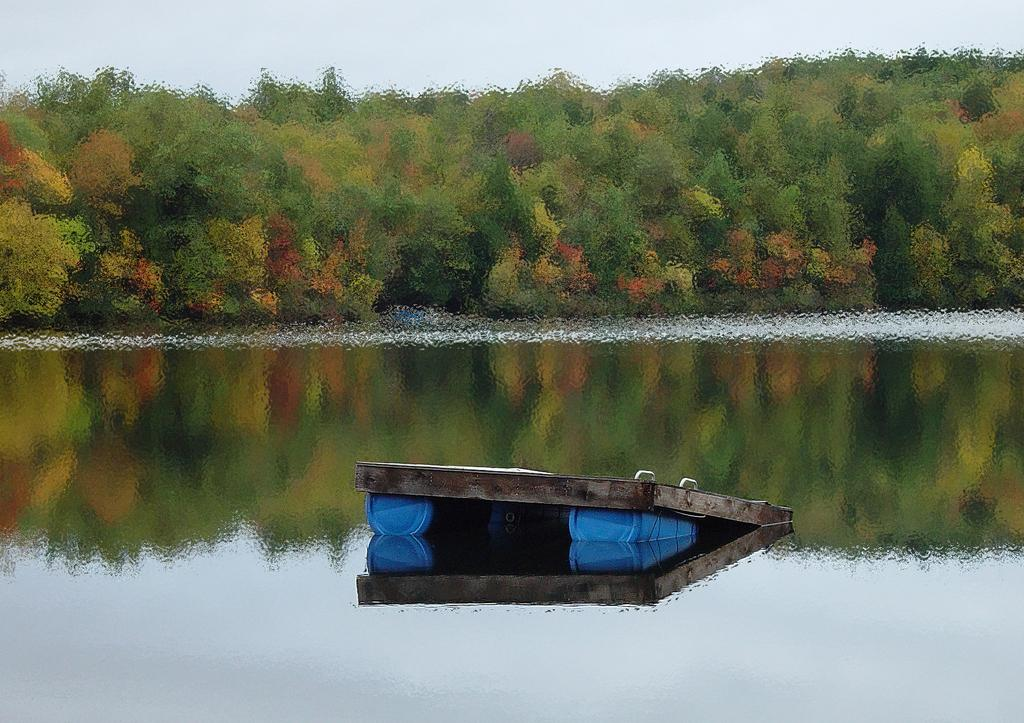What is floating on the water in the image? There is a barrel raft in the water. What can be seen in the middle of the image? There are trees in the middle of the image. What is visible at the top of the image? The sky is visible at the top of the image. How many slaves are visible on the barrel raft in the image? There are no slaves present in the image; it features a barrel raft in the water. Can you see a tiger walking on the barrel raft in the image? There is no tiger present on the barrel raft in the image. 